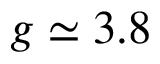Convert formula to latex. <formula><loc_0><loc_0><loc_500><loc_500>g \simeq 3 . 8</formula> 